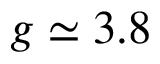Convert formula to latex. <formula><loc_0><loc_0><loc_500><loc_500>g \simeq 3 . 8</formula> 